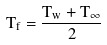<formula> <loc_0><loc_0><loc_500><loc_500>T _ { f } = \frac { T _ { w } + T _ { \infty } } { 2 }</formula> 